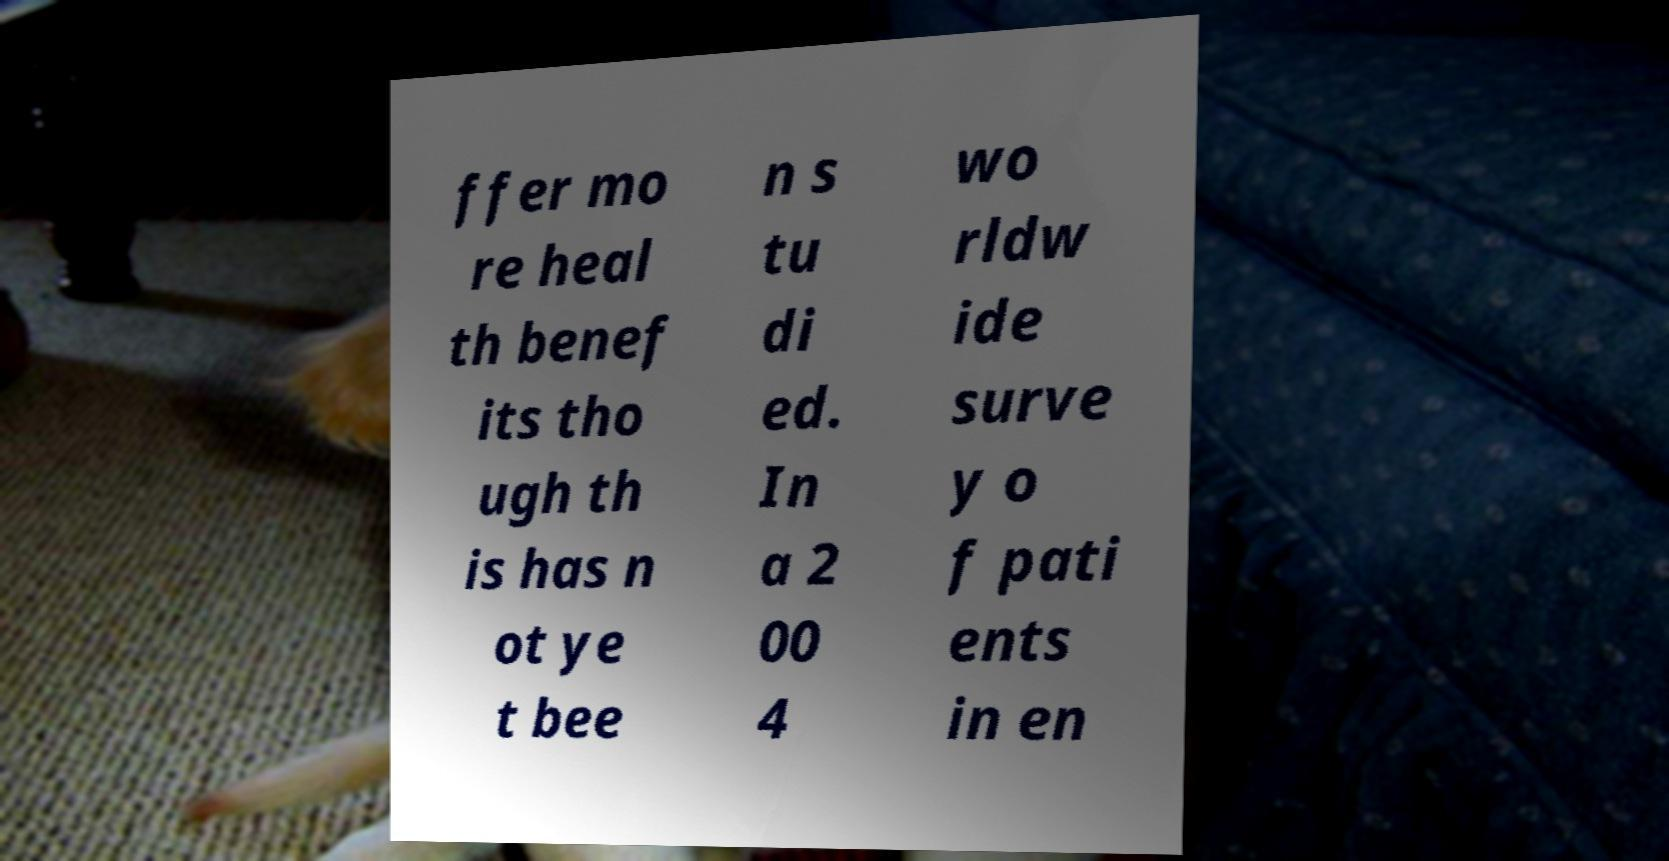Can you read and provide the text displayed in the image?This photo seems to have some interesting text. Can you extract and type it out for me? ffer mo re heal th benef its tho ugh th is has n ot ye t bee n s tu di ed. In a 2 00 4 wo rldw ide surve y o f pati ents in en 